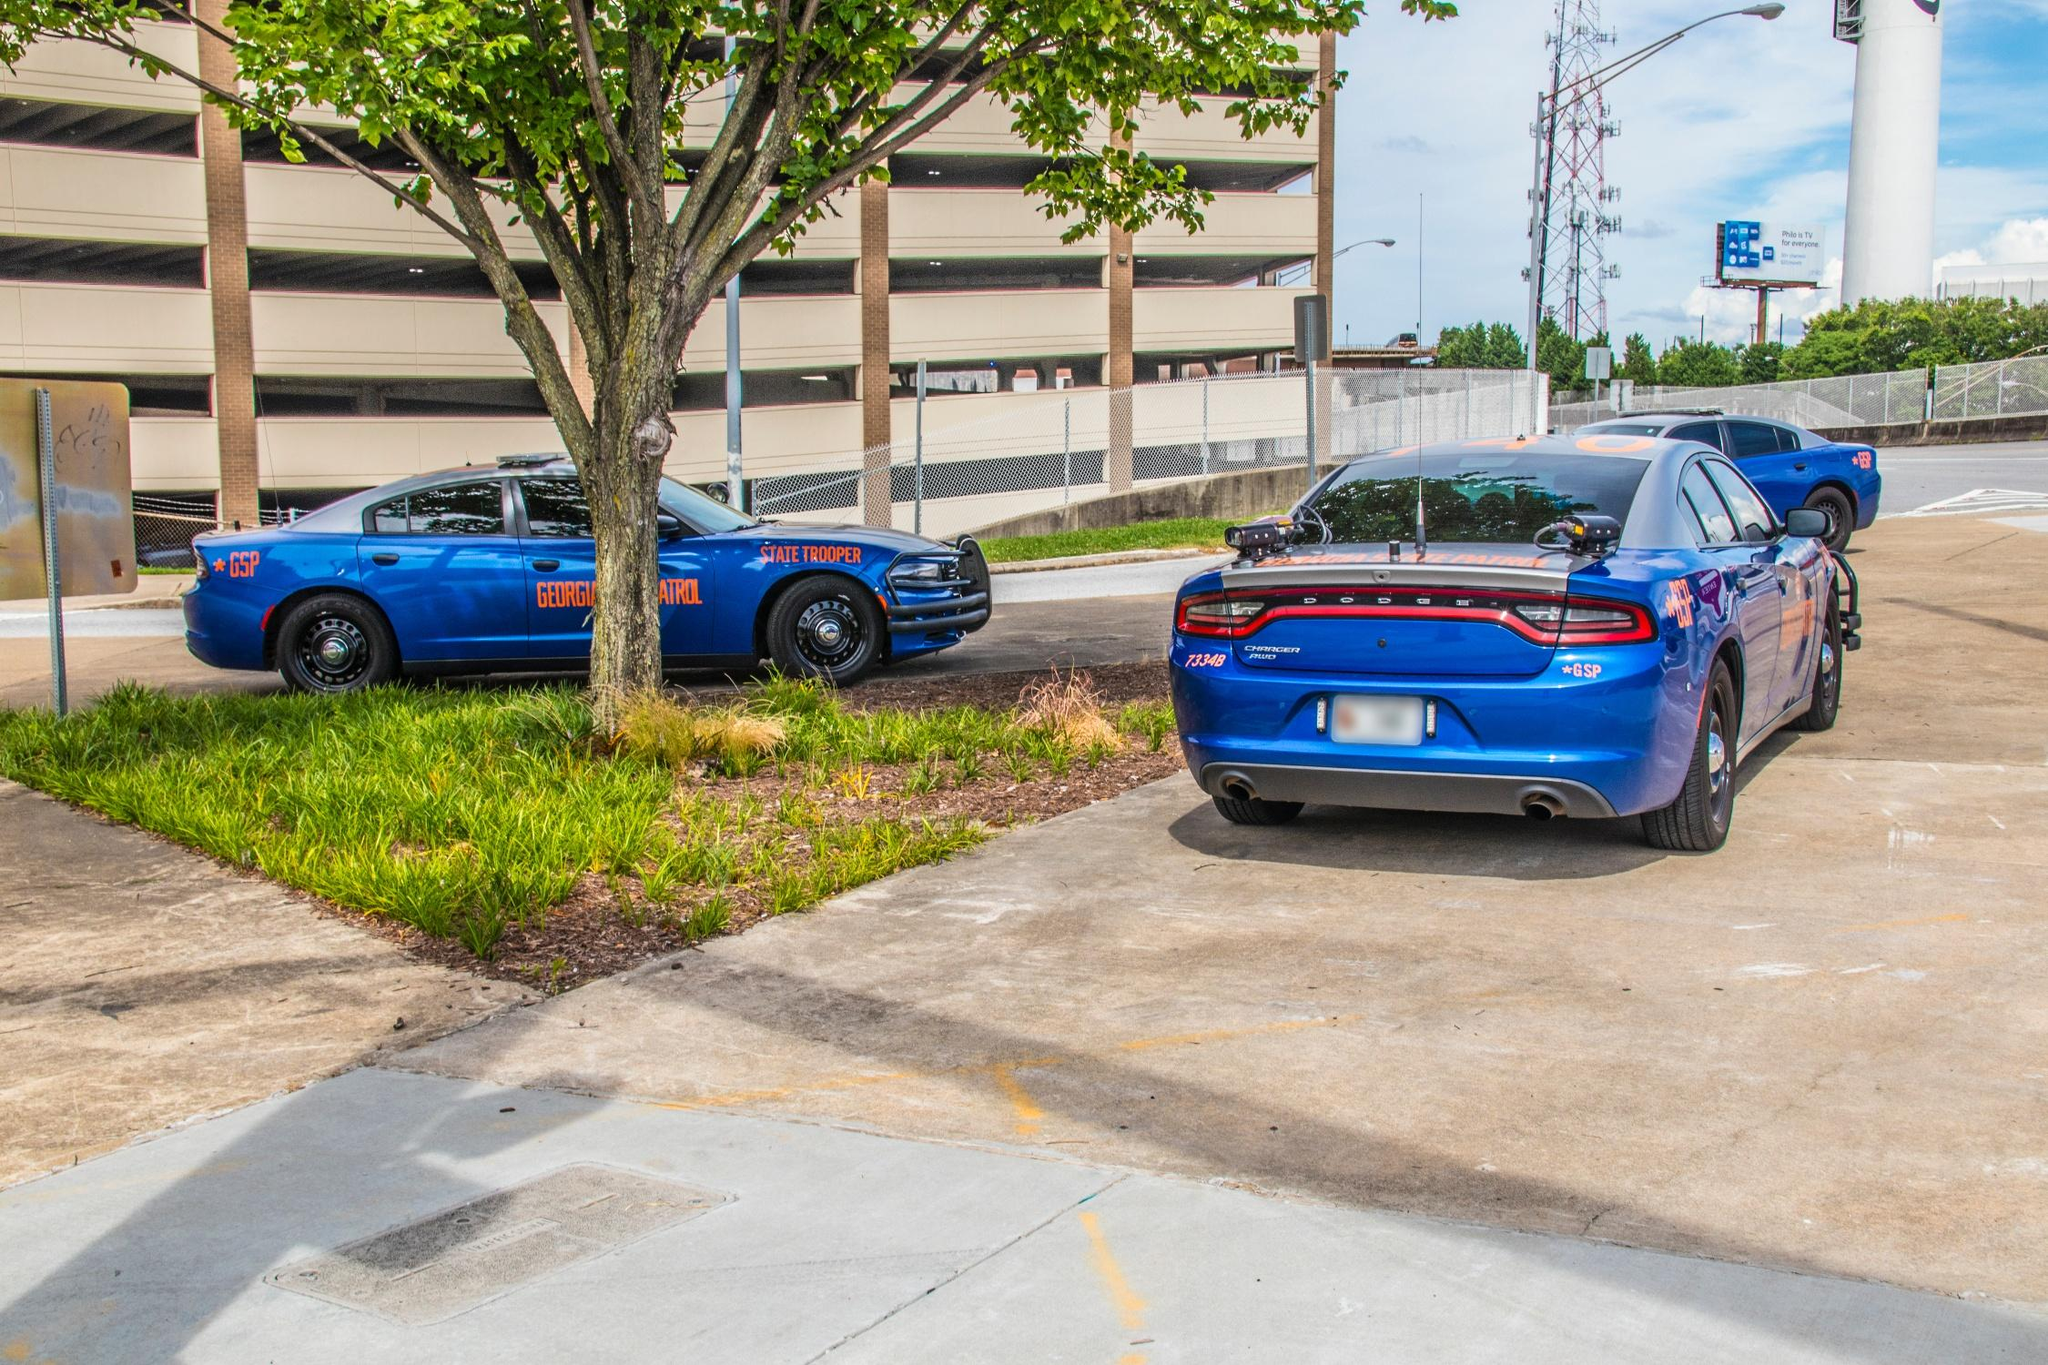What does the presence of two different types of patrol cars suggest about the operations at this location? The presence of two different types of patrol cars, one being a standard patrol unit and the other a K-9 unit, suggests a diverse range of police activities possibly occurring at this location. The standard unit can handle various law enforcement tasks, like traffic stops or rapid response to incidents, while the K-9 unit is likely specialized in search and detection operations, possibly for drugs or explosives. This setup indicates a strategic point for versatile law enforcement coverage that can adapt to multiple scenarios, enhancing security and safety in the area. 